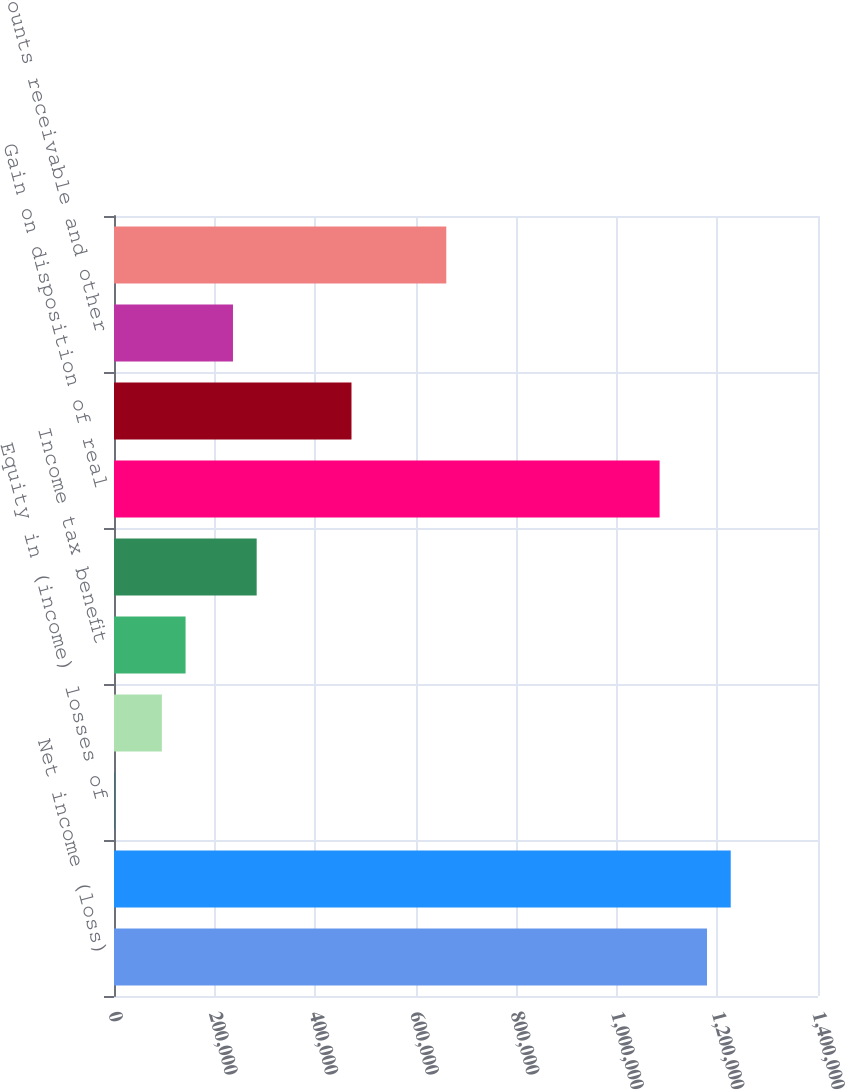Convert chart to OTSL. <chart><loc_0><loc_0><loc_500><loc_500><bar_chart><fcel>Net income (loss)<fcel>Depreciation and amortization<fcel>Equity in (income) losses of<fcel>Gain on dispositions of<fcel>Income tax benefit<fcel>Share-based compensation<fcel>Gain on disposition of real<fcel>Other adjustments to income<fcel>Accounts receivable and other<fcel>Accounts payable accrued<nl><fcel>1.1793e+06<fcel>1.22644e+06<fcel>926<fcel>95196<fcel>142331<fcel>283736<fcel>1.08503e+06<fcel>472276<fcel>236601<fcel>660816<nl></chart> 